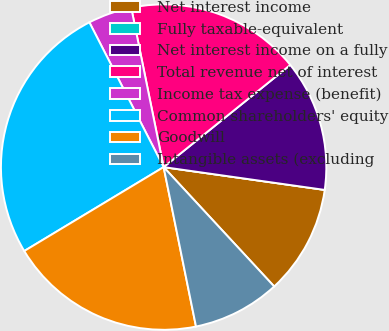Convert chart to OTSL. <chart><loc_0><loc_0><loc_500><loc_500><pie_chart><fcel>Net interest income<fcel>Fully taxable-equivalent<fcel>Net interest income on a fully<fcel>Total revenue net of interest<fcel>Income tax expense (benefit)<fcel>Common shareholders' equity<fcel>Goodwill<fcel>Intangible assets (excluding<nl><fcel>10.87%<fcel>0.0%<fcel>13.04%<fcel>17.39%<fcel>4.35%<fcel>26.08%<fcel>19.56%<fcel>8.7%<nl></chart> 